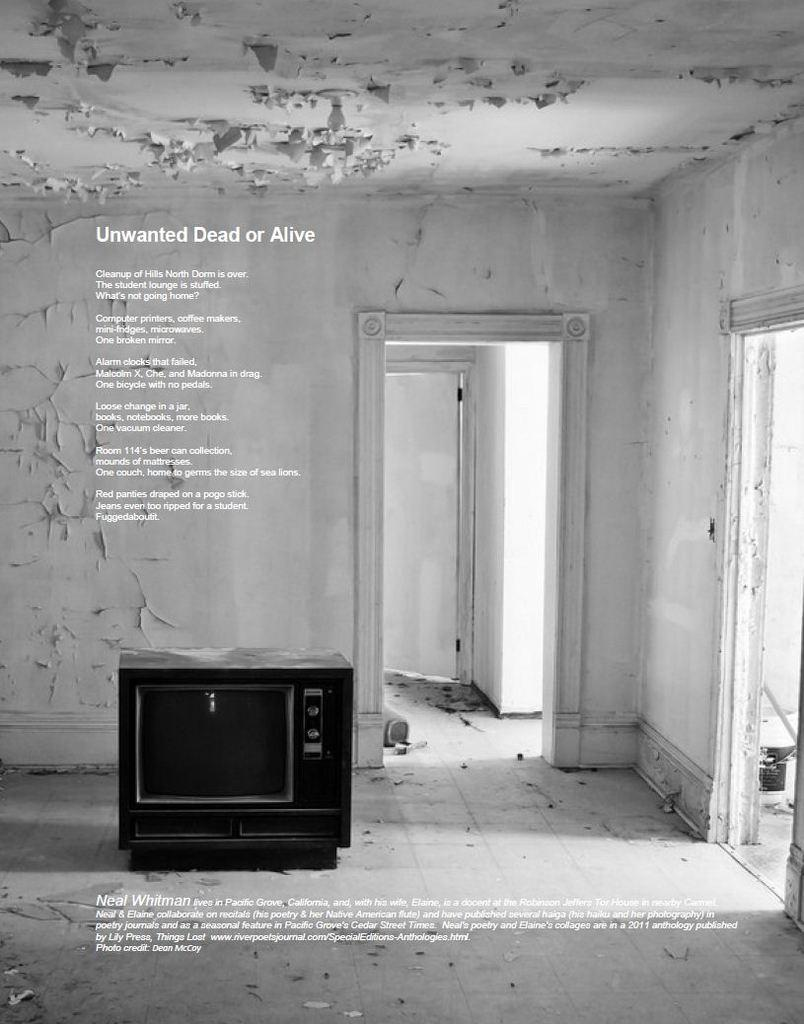<image>
Relay a brief, clear account of the picture shown. a black and white image of an almost empty room with a text starting with unwanted dead or alive written at the top 